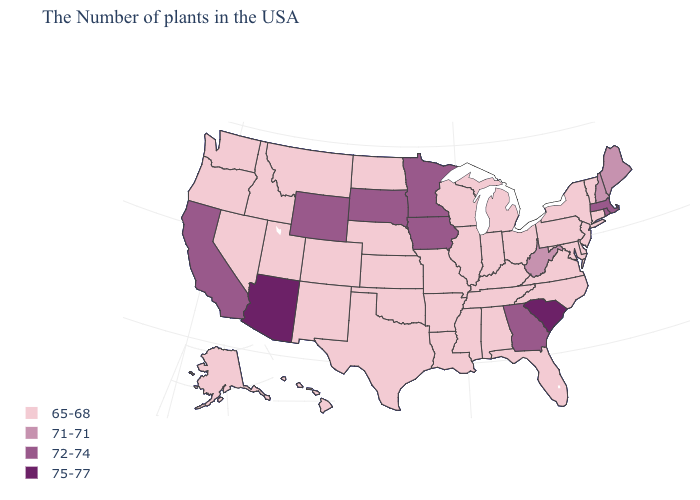Does Massachusetts have the lowest value in the USA?
Concise answer only. No. What is the value of Utah?
Quick response, please. 65-68. Does Florida have a higher value than Maryland?
Short answer required. No. Does South Dakota have a lower value than South Carolina?
Be succinct. Yes. Which states have the lowest value in the Northeast?
Quick response, please. Vermont, Connecticut, New York, New Jersey, Pennsylvania. Which states have the lowest value in the Northeast?
Keep it brief. Vermont, Connecticut, New York, New Jersey, Pennsylvania. Does Colorado have the highest value in the West?
Answer briefly. No. Name the states that have a value in the range 71-71?
Give a very brief answer. Maine, New Hampshire, West Virginia. What is the value of Hawaii?
Give a very brief answer. 65-68. Name the states that have a value in the range 72-74?
Give a very brief answer. Massachusetts, Rhode Island, Georgia, Minnesota, Iowa, South Dakota, Wyoming, California. Does Alaska have a lower value than Arizona?
Be succinct. Yes. What is the highest value in the USA?
Be succinct. 75-77. Does Hawaii have the lowest value in the USA?
Concise answer only. Yes. What is the highest value in the MidWest ?
Be succinct. 72-74. Name the states that have a value in the range 75-77?
Write a very short answer. South Carolina, Arizona. 